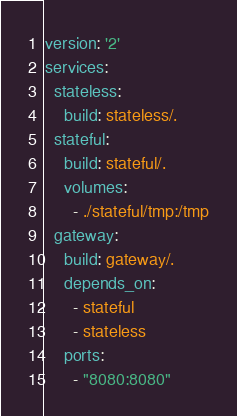Convert code to text. <code><loc_0><loc_0><loc_500><loc_500><_YAML_>version: '2'
services:
  stateless:
    build: stateless/.
  stateful:
    build: stateful/.
    volumes:
      - ./stateful/tmp:/tmp
  gateway:
    build: gateway/.
    depends_on:
      - stateful
      - stateless
    ports:
      - "8080:8080"

</code> 